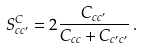Convert formula to latex. <formula><loc_0><loc_0><loc_500><loc_500>S ^ { C } _ { c c ^ { \prime } } = 2 \frac { C _ { c c ^ { \prime } } } { C _ { c c } + C _ { c ^ { \prime } c ^ { \prime } } } \, .</formula> 